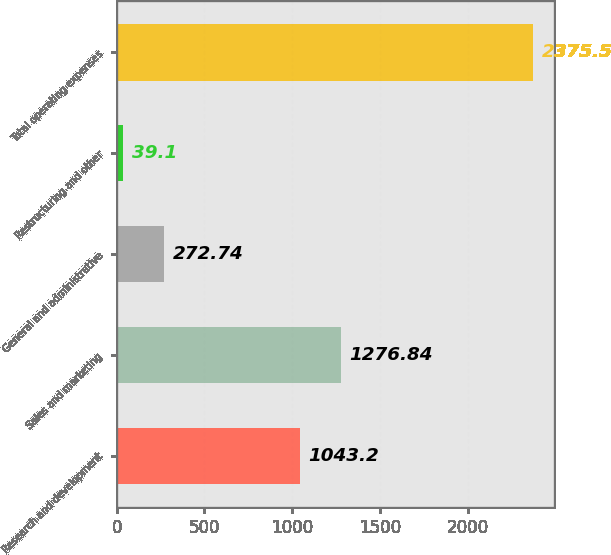Convert chart. <chart><loc_0><loc_0><loc_500><loc_500><bar_chart><fcel>Research and development<fcel>Sales and marketing<fcel>General and administrative<fcel>Restructuring and other<fcel>Total operating expenses<nl><fcel>1043.2<fcel>1276.84<fcel>272.74<fcel>39.1<fcel>2375.5<nl></chart> 